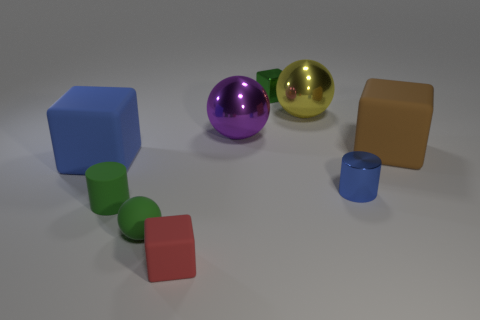Are there an equal number of tiny blue objects that are on the left side of the purple ball and red rubber things?
Keep it short and to the point. No. Are there any big purple shiny things to the left of the purple object?
Keep it short and to the point. No. Does the big blue object have the same shape as the small shiny object that is right of the small green metal cube?
Provide a short and direct response. No. There is a tiny cylinder that is the same material as the brown block; what color is it?
Offer a terse response. Green. Are there the same number of blue shiny cylinders and metallic objects?
Ensure brevity in your answer.  No. What is the color of the matte ball?
Your response must be concise. Green. Are the red object and the small cube that is to the right of the red rubber block made of the same material?
Make the answer very short. No. What number of cubes are in front of the matte cylinder and behind the small shiny cylinder?
Your answer should be compact. 0. There is a red thing that is the same size as the shiny cylinder; what shape is it?
Ensure brevity in your answer.  Cube. Is there a big sphere behind the tiny metal object behind the large block to the right of the small red rubber cube?
Keep it short and to the point. No. 